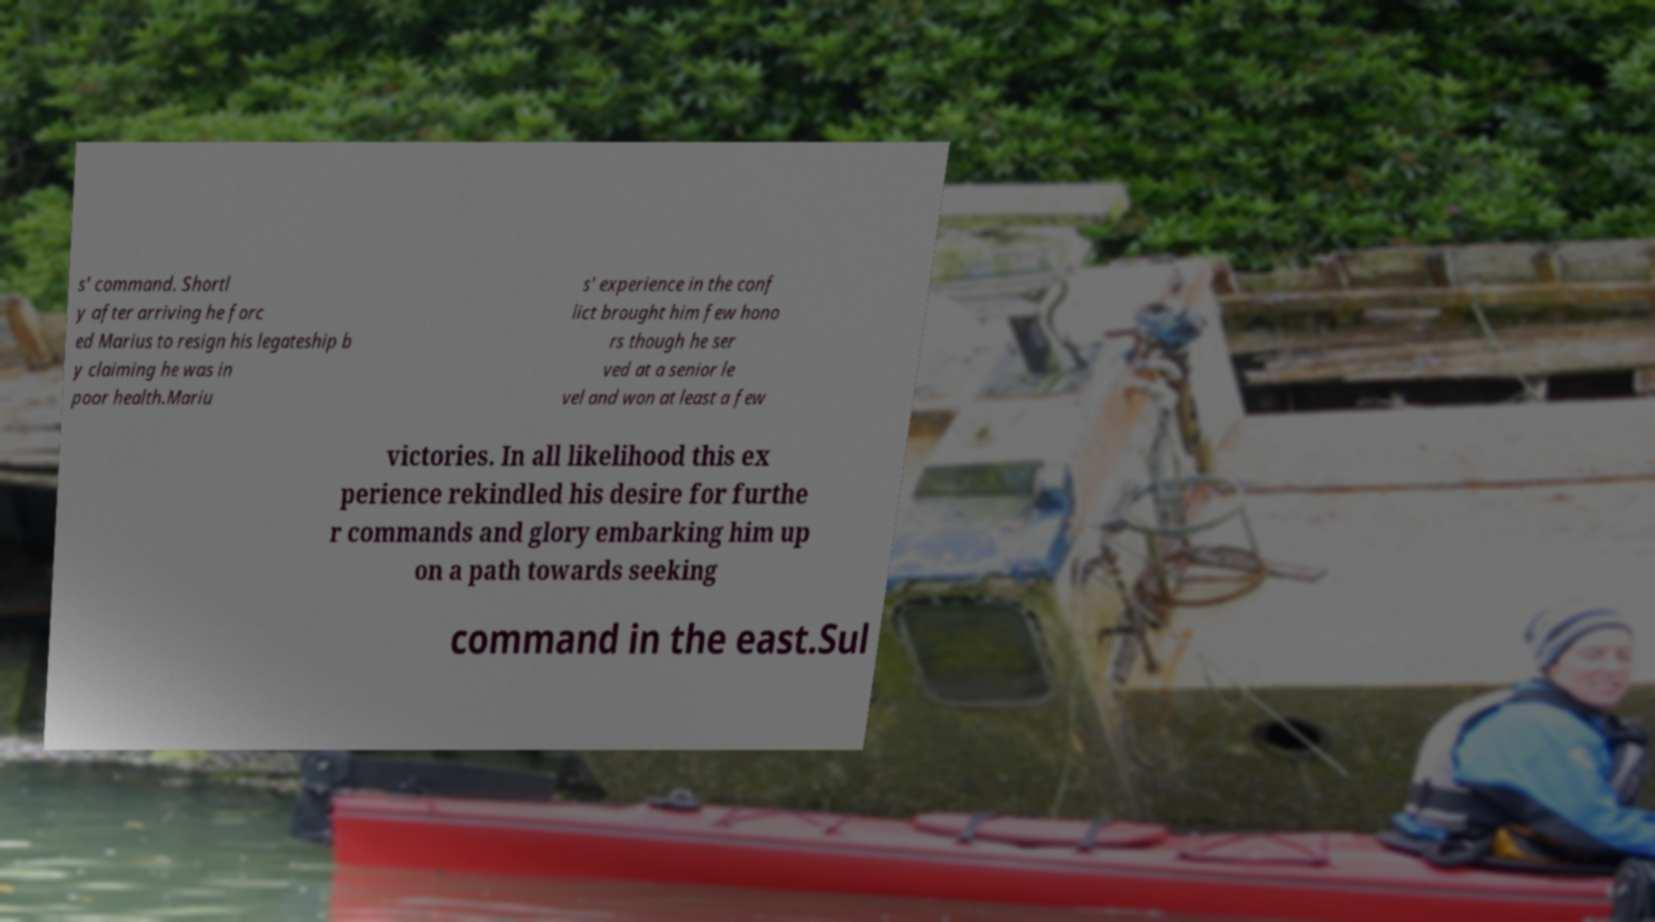Can you accurately transcribe the text from the provided image for me? s' command. Shortl y after arriving he forc ed Marius to resign his legateship b y claiming he was in poor health.Mariu s' experience in the conf lict brought him few hono rs though he ser ved at a senior le vel and won at least a few victories. In all likelihood this ex perience rekindled his desire for furthe r commands and glory embarking him up on a path towards seeking command in the east.Sul 